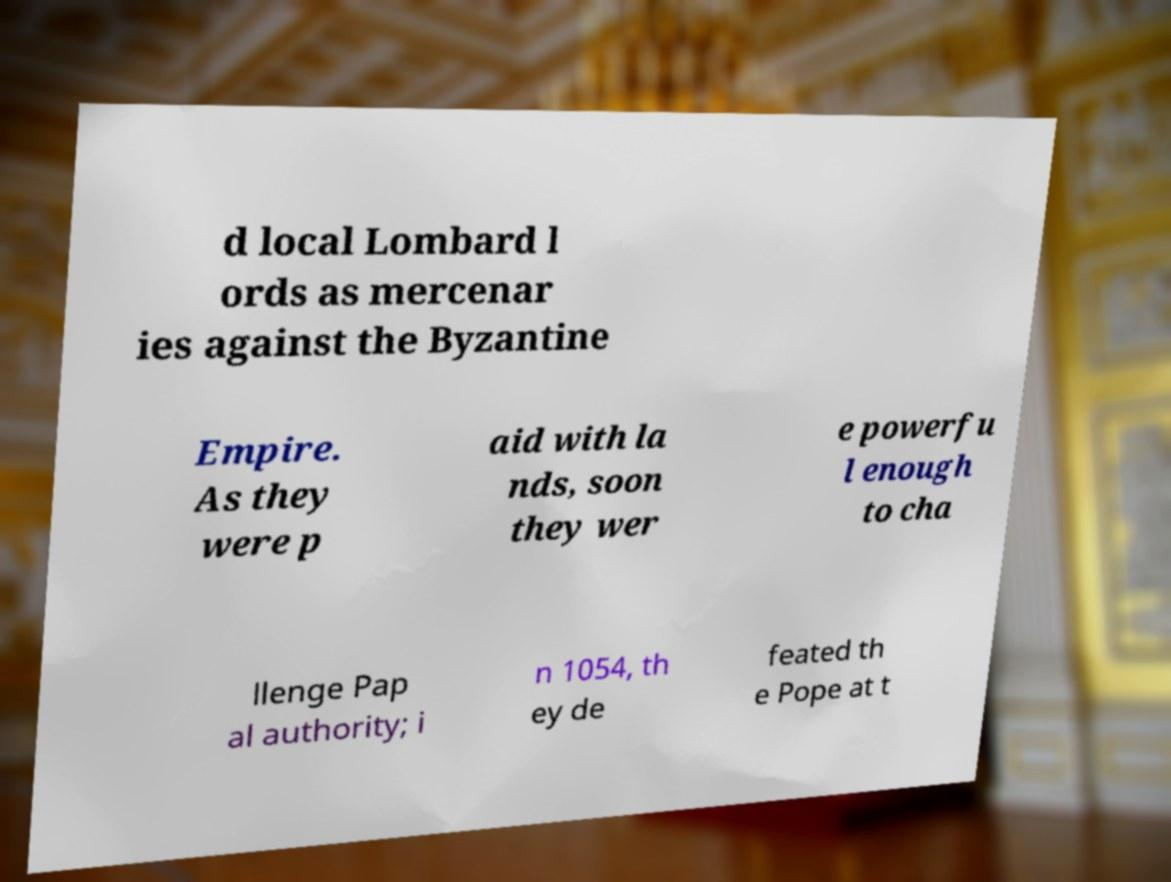Can you read and provide the text displayed in the image?This photo seems to have some interesting text. Can you extract and type it out for me? d local Lombard l ords as mercenar ies against the Byzantine Empire. As they were p aid with la nds, soon they wer e powerfu l enough to cha llenge Pap al authority; i n 1054, th ey de feated th e Pope at t 